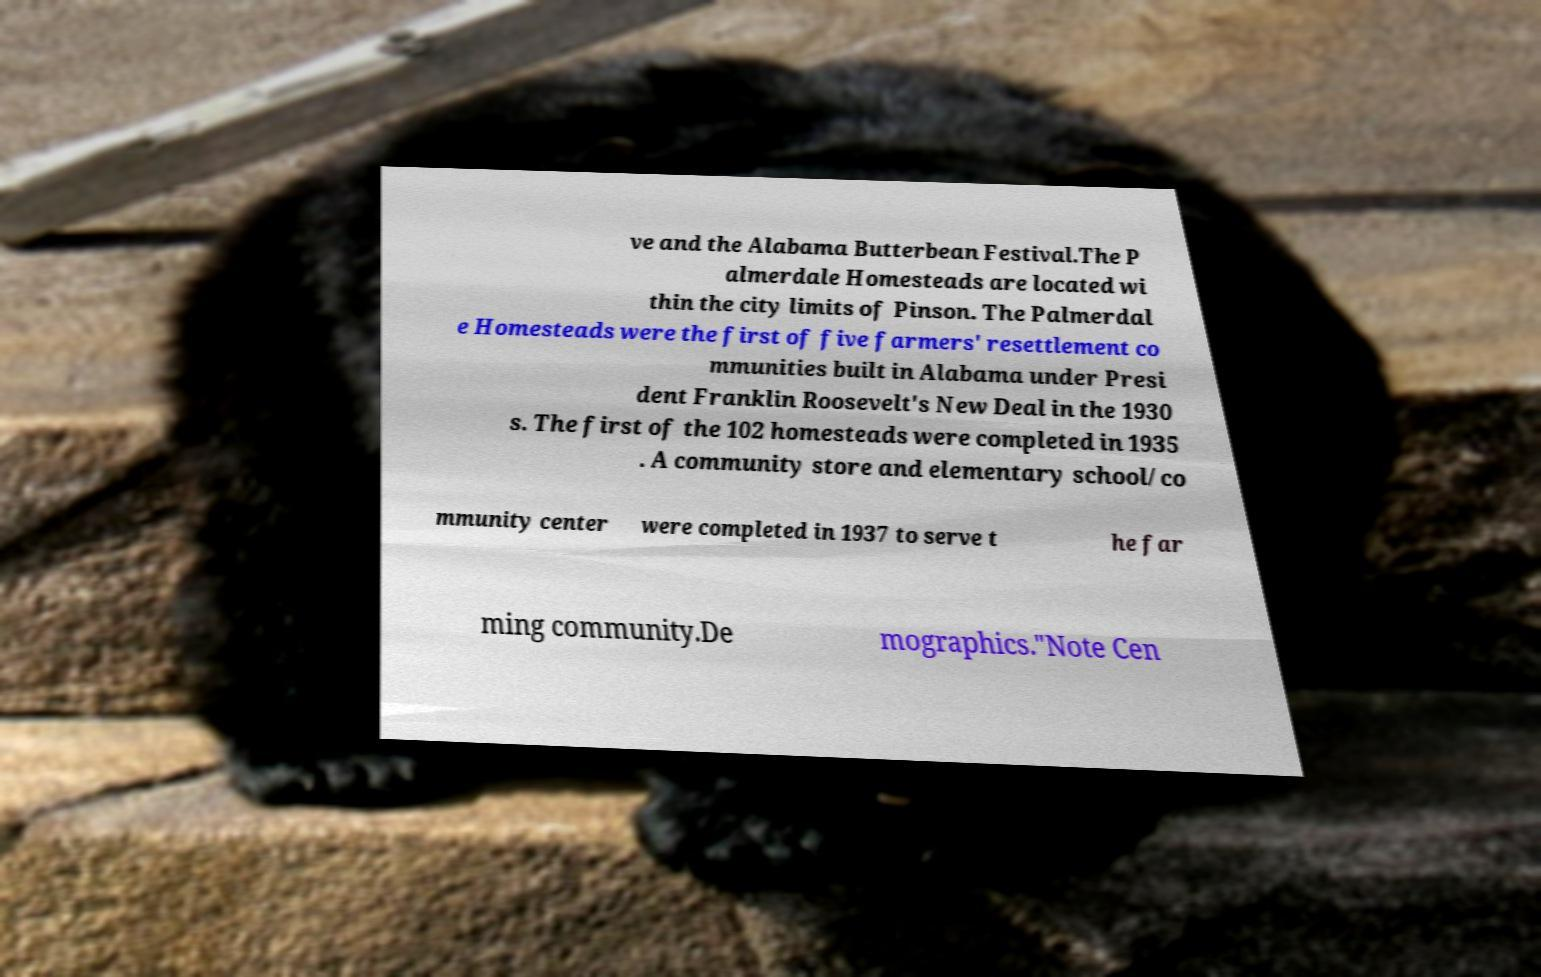Please read and relay the text visible in this image. What does it say? ve and the Alabama Butterbean Festival.The P almerdale Homesteads are located wi thin the city limits of Pinson. The Palmerdal e Homesteads were the first of five farmers' resettlement co mmunities built in Alabama under Presi dent Franklin Roosevelt's New Deal in the 1930 s. The first of the 102 homesteads were completed in 1935 . A community store and elementary school/co mmunity center were completed in 1937 to serve t he far ming community.De mographics."Note Cen 